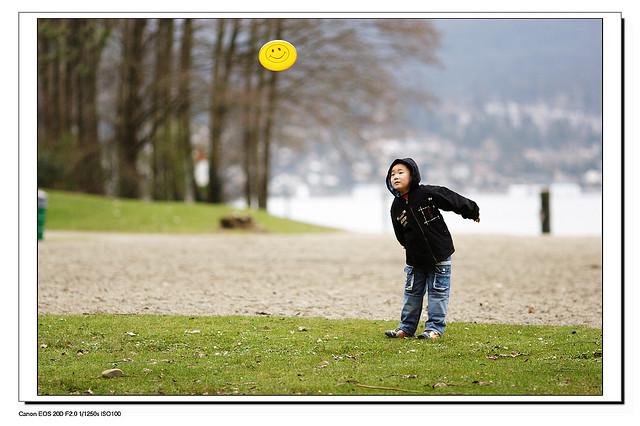What is the kid playing with?
Give a very brief answer. Frisbee. Does this person have a covering on his head?
Short answer required. Yes. What kind of image is on the Frisbee?
Short answer required. Smiley face. 